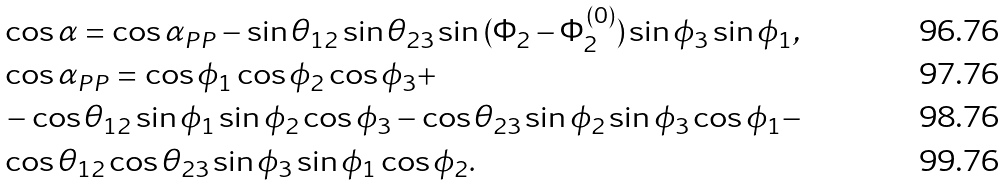Convert formula to latex. <formula><loc_0><loc_0><loc_500><loc_500>& \cos \alpha = \cos { \alpha _ { P P } } - \sin { \theta _ { 1 2 } } \sin { \theta _ { 2 3 } } \sin { ( \Phi _ { 2 } - \Phi _ { 2 } ^ { ( 0 ) } ) } \sin { \phi } _ { 3 } \sin { \phi } _ { 1 } , \\ & \cos \alpha _ { P P } = \cos { \phi } _ { 1 } \cos { \phi } _ { 2 } \cos { \phi } _ { 3 } + \\ & - \cos { \theta _ { 1 2 } } \sin { \phi } _ { 1 } \sin { \phi } _ { 2 } \cos { \phi } _ { 3 } - \cos { \theta _ { 2 3 } } \sin { \phi } _ { 2 } \sin { \phi } _ { 3 } \cos { \phi } _ { 1 } - \\ & \cos { \theta _ { 1 2 } } \cos { \theta _ { 2 3 } } \sin { \phi } _ { 3 } \sin { \phi } _ { 1 } \cos { \phi } _ { 2 } .</formula> 